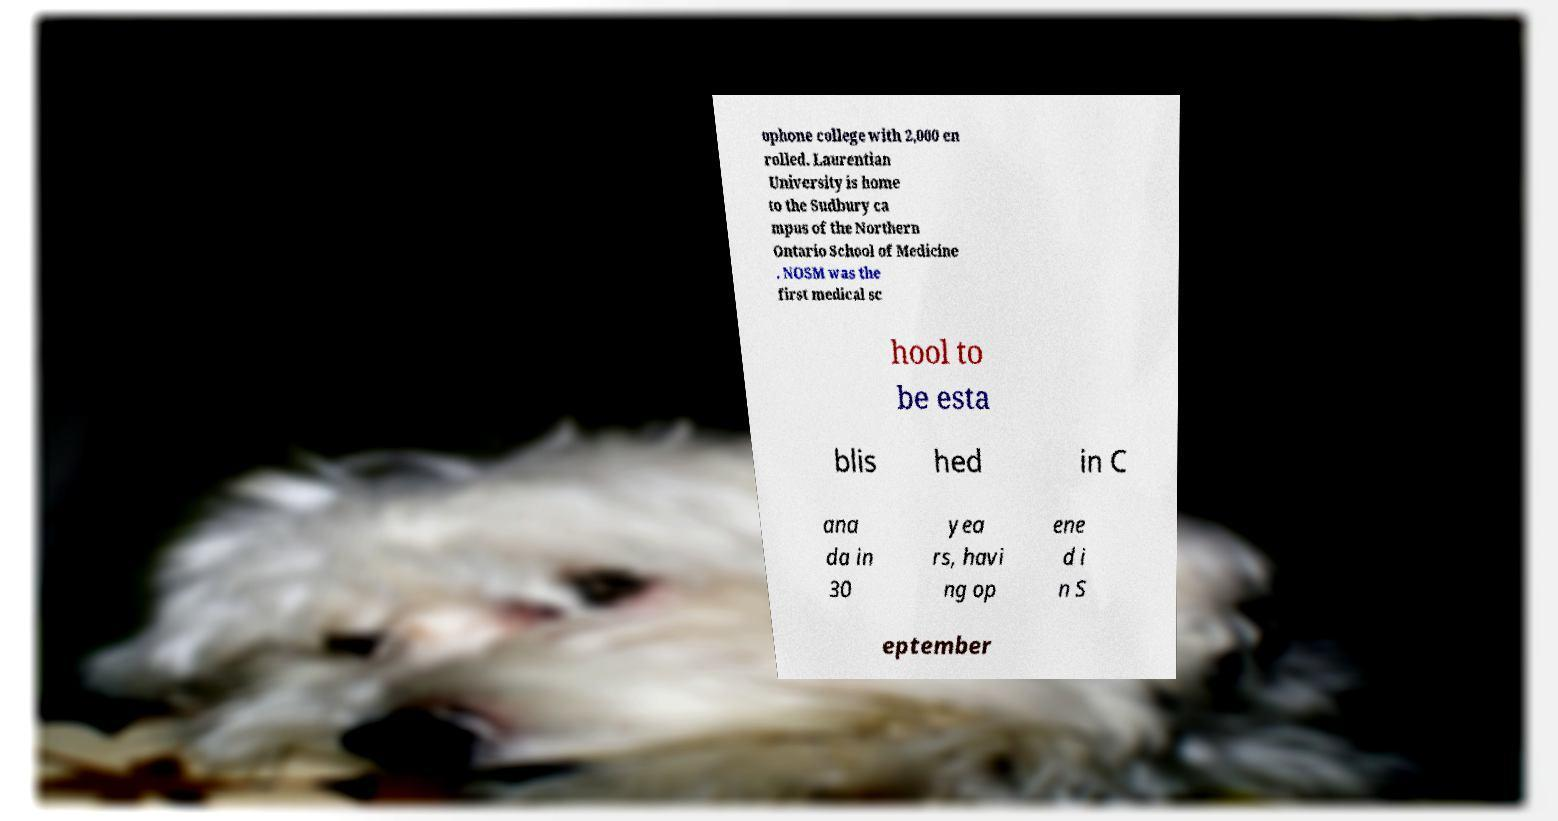What messages or text are displayed in this image? I need them in a readable, typed format. ophone college with 2,000 en rolled. Laurentian University is home to the Sudbury ca mpus of the Northern Ontario School of Medicine . NOSM was the first medical sc hool to be esta blis hed in C ana da in 30 yea rs, havi ng op ene d i n S eptember 